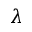<formula> <loc_0><loc_0><loc_500><loc_500>\lambda</formula> 